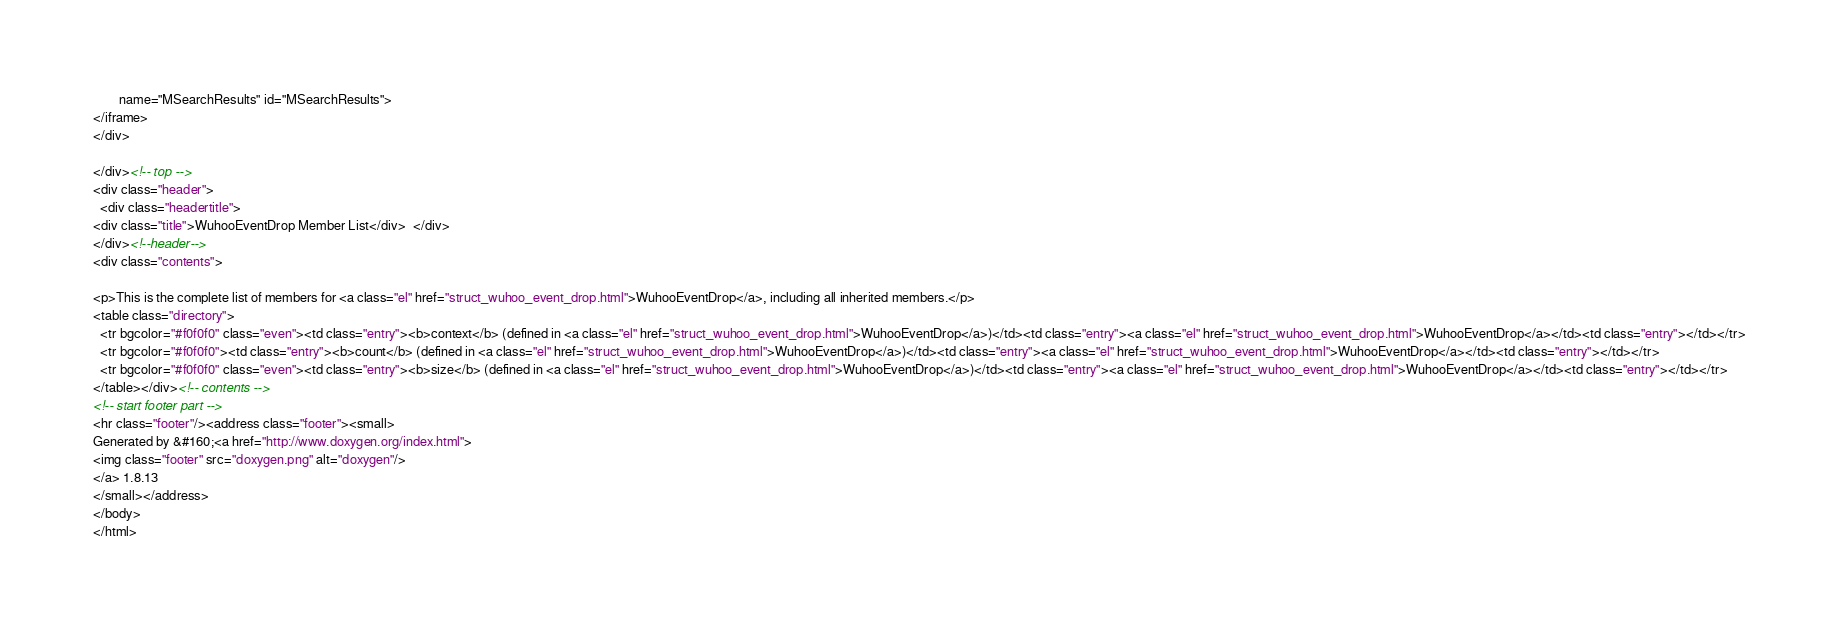Convert code to text. <code><loc_0><loc_0><loc_500><loc_500><_HTML_>        name="MSearchResults" id="MSearchResults">
</iframe>
</div>

</div><!-- top -->
<div class="header">
  <div class="headertitle">
<div class="title">WuhooEventDrop Member List</div>  </div>
</div><!--header-->
<div class="contents">

<p>This is the complete list of members for <a class="el" href="struct_wuhoo_event_drop.html">WuhooEventDrop</a>, including all inherited members.</p>
<table class="directory">
  <tr bgcolor="#f0f0f0" class="even"><td class="entry"><b>context</b> (defined in <a class="el" href="struct_wuhoo_event_drop.html">WuhooEventDrop</a>)</td><td class="entry"><a class="el" href="struct_wuhoo_event_drop.html">WuhooEventDrop</a></td><td class="entry"></td></tr>
  <tr bgcolor="#f0f0f0"><td class="entry"><b>count</b> (defined in <a class="el" href="struct_wuhoo_event_drop.html">WuhooEventDrop</a>)</td><td class="entry"><a class="el" href="struct_wuhoo_event_drop.html">WuhooEventDrop</a></td><td class="entry"></td></tr>
  <tr bgcolor="#f0f0f0" class="even"><td class="entry"><b>size</b> (defined in <a class="el" href="struct_wuhoo_event_drop.html">WuhooEventDrop</a>)</td><td class="entry"><a class="el" href="struct_wuhoo_event_drop.html">WuhooEventDrop</a></td><td class="entry"></td></tr>
</table></div><!-- contents -->
<!-- start footer part -->
<hr class="footer"/><address class="footer"><small>
Generated by &#160;<a href="http://www.doxygen.org/index.html">
<img class="footer" src="doxygen.png" alt="doxygen"/>
</a> 1.8.13
</small></address>
</body>
</html>
</code> 